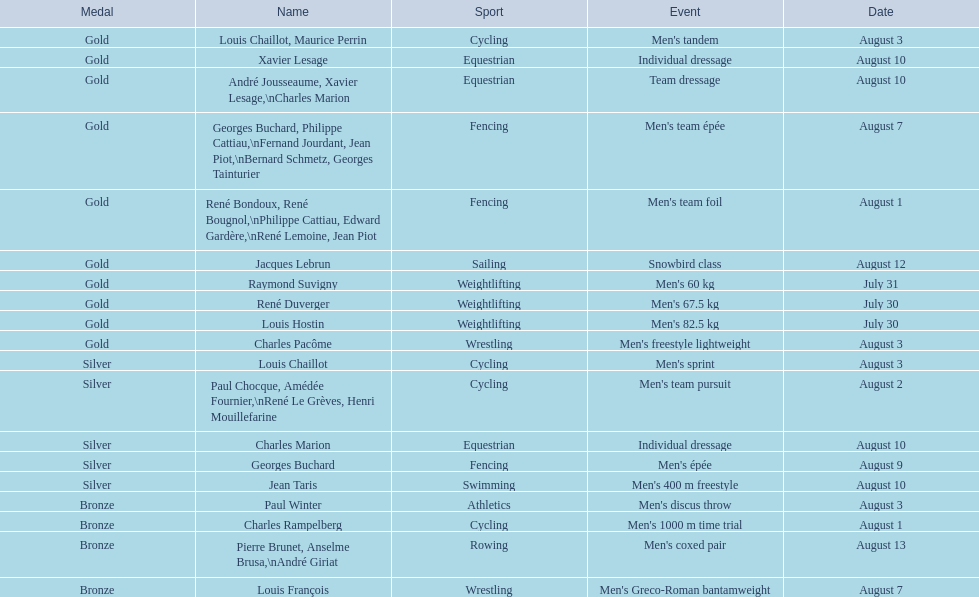How many gold awards were won by this country in these olympics? 10. 